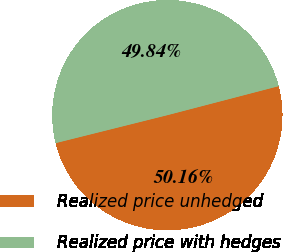Convert chart. <chart><loc_0><loc_0><loc_500><loc_500><pie_chart><fcel>Realized price unhedged<fcel>Realized price with hedges<nl><fcel>50.16%<fcel>49.84%<nl></chart> 